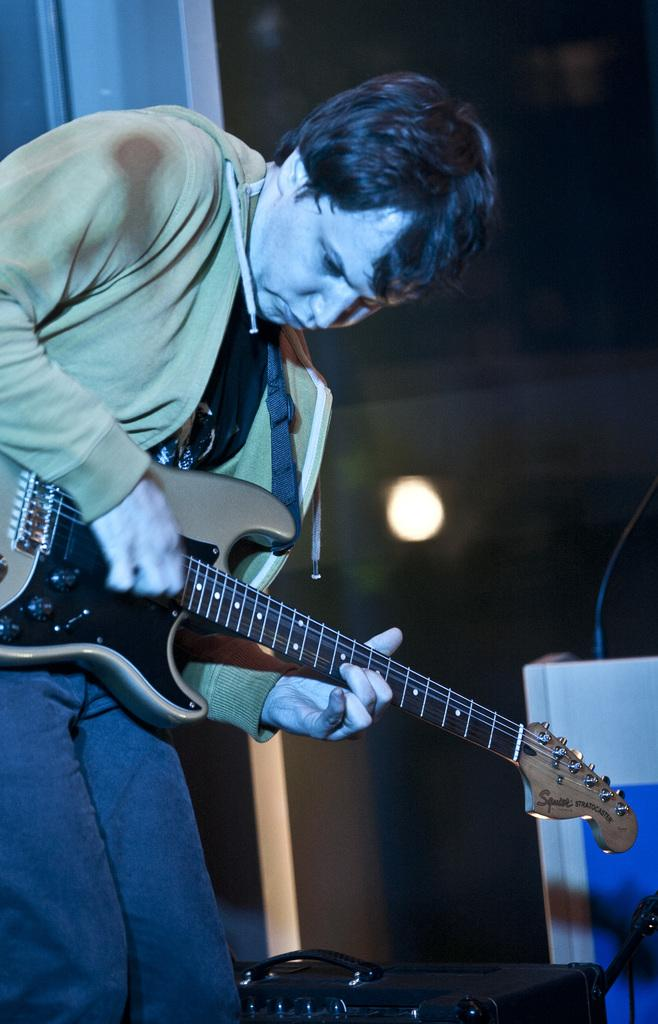What is the main subject of the image? There is a person in the image. What is the person holding in the image? The person is holding a guitar. Can you describe the background of the image? There is a light in the background of the image. What type of health adjustment is the person making in the image? There is no indication in the image that the person is making any health adjustments. 